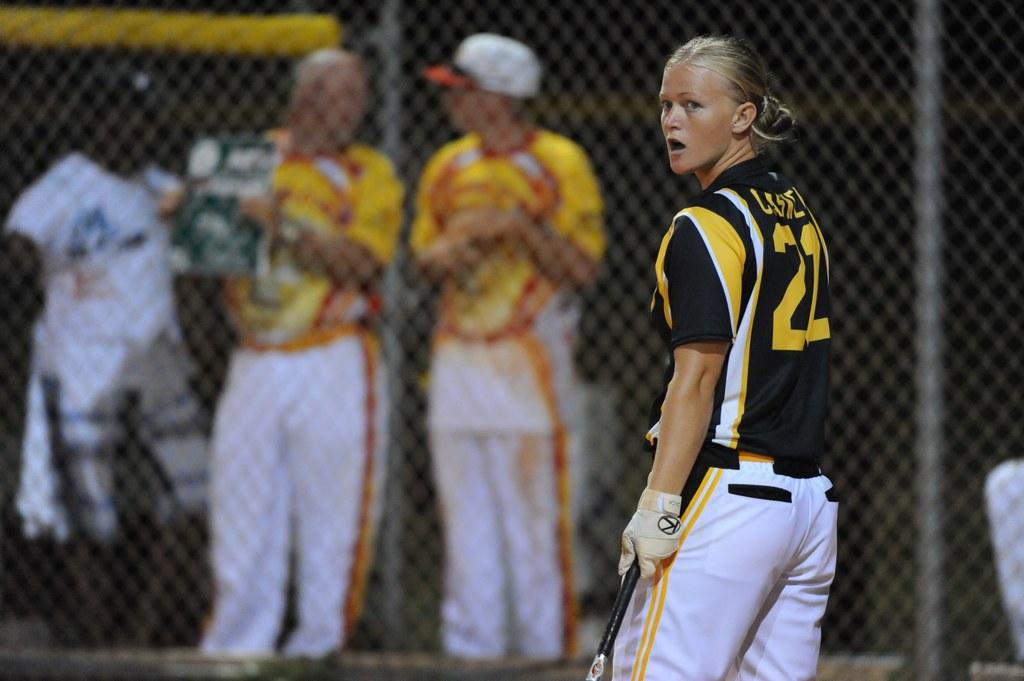What is the main subject of the image? There is a woman standing in the image. What is the woman holding in the image? The woman is holding an object. What can be seen in the background of the image? In the background, there are three persons standing. What is the purpose of the fence in the image? The fence serves as a barrier or boundary in the image. What type of bomb can be seen in the woman's hand in the image? There is no bomb present in the image; the woman is holding an object, but it is not a bomb. 